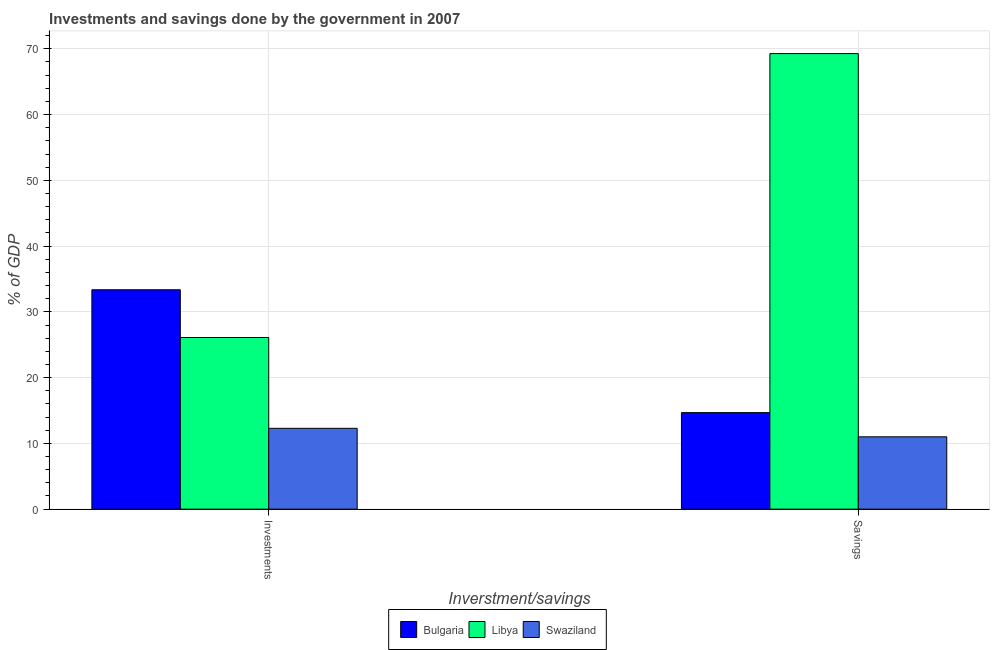How many different coloured bars are there?
Offer a very short reply. 3. Are the number of bars on each tick of the X-axis equal?
Your answer should be very brief. Yes. How many bars are there on the 1st tick from the right?
Make the answer very short. 3. What is the label of the 1st group of bars from the left?
Your answer should be very brief. Investments. What is the investments of government in Swaziland?
Ensure brevity in your answer.  12.29. Across all countries, what is the maximum savings of government?
Offer a terse response. 69.28. Across all countries, what is the minimum savings of government?
Your answer should be very brief. 11. In which country was the savings of government maximum?
Provide a succinct answer. Libya. In which country was the savings of government minimum?
Provide a short and direct response. Swaziland. What is the total investments of government in the graph?
Provide a succinct answer. 71.75. What is the difference between the savings of government in Swaziland and that in Bulgaria?
Keep it short and to the point. -3.68. What is the difference between the savings of government in Swaziland and the investments of government in Bulgaria?
Offer a very short reply. -22.36. What is the average savings of government per country?
Your answer should be compact. 31.65. What is the difference between the savings of government and investments of government in Bulgaria?
Your response must be concise. -18.68. What is the ratio of the investments of government in Bulgaria to that in Libya?
Give a very brief answer. 1.28. Is the investments of government in Bulgaria less than that in Libya?
Your answer should be very brief. No. In how many countries, is the investments of government greater than the average investments of government taken over all countries?
Your response must be concise. 2. What does the 3rd bar from the left in Savings represents?
Provide a short and direct response. Swaziland. What does the 1st bar from the right in Investments represents?
Your answer should be very brief. Swaziland. How many bars are there?
Make the answer very short. 6. Are all the bars in the graph horizontal?
Your answer should be very brief. No. How many countries are there in the graph?
Ensure brevity in your answer.  3. Does the graph contain grids?
Ensure brevity in your answer.  Yes. How many legend labels are there?
Your response must be concise. 3. What is the title of the graph?
Your response must be concise. Investments and savings done by the government in 2007. Does "Canada" appear as one of the legend labels in the graph?
Your answer should be compact. No. What is the label or title of the X-axis?
Your answer should be very brief. Inverstment/savings. What is the label or title of the Y-axis?
Ensure brevity in your answer.  % of GDP. What is the % of GDP in Bulgaria in Investments?
Your answer should be very brief. 33.36. What is the % of GDP of Libya in Investments?
Ensure brevity in your answer.  26.1. What is the % of GDP of Swaziland in Investments?
Ensure brevity in your answer.  12.29. What is the % of GDP in Bulgaria in Savings?
Offer a very short reply. 14.68. What is the % of GDP of Libya in Savings?
Your answer should be compact. 69.28. What is the % of GDP of Swaziland in Savings?
Offer a very short reply. 11. Across all Inverstment/savings, what is the maximum % of GDP in Bulgaria?
Your response must be concise. 33.36. Across all Inverstment/savings, what is the maximum % of GDP in Libya?
Ensure brevity in your answer.  69.28. Across all Inverstment/savings, what is the maximum % of GDP in Swaziland?
Ensure brevity in your answer.  12.29. Across all Inverstment/savings, what is the minimum % of GDP in Bulgaria?
Your response must be concise. 14.68. Across all Inverstment/savings, what is the minimum % of GDP in Libya?
Make the answer very short. 26.1. Across all Inverstment/savings, what is the minimum % of GDP of Swaziland?
Your response must be concise. 11. What is the total % of GDP in Bulgaria in the graph?
Your response must be concise. 48.04. What is the total % of GDP of Libya in the graph?
Keep it short and to the point. 95.38. What is the total % of GDP in Swaziland in the graph?
Give a very brief answer. 23.29. What is the difference between the % of GDP of Bulgaria in Investments and that in Savings?
Keep it short and to the point. 18.68. What is the difference between the % of GDP of Libya in Investments and that in Savings?
Ensure brevity in your answer.  -43.17. What is the difference between the % of GDP in Swaziland in Investments and that in Savings?
Offer a very short reply. 1.29. What is the difference between the % of GDP of Bulgaria in Investments and the % of GDP of Libya in Savings?
Offer a very short reply. -35.91. What is the difference between the % of GDP of Bulgaria in Investments and the % of GDP of Swaziland in Savings?
Make the answer very short. 22.36. What is the difference between the % of GDP of Libya in Investments and the % of GDP of Swaziland in Savings?
Provide a short and direct response. 15.1. What is the average % of GDP of Bulgaria per Inverstment/savings?
Keep it short and to the point. 24.02. What is the average % of GDP in Libya per Inverstment/savings?
Give a very brief answer. 47.69. What is the average % of GDP in Swaziland per Inverstment/savings?
Your answer should be very brief. 11.65. What is the difference between the % of GDP of Bulgaria and % of GDP of Libya in Investments?
Give a very brief answer. 7.26. What is the difference between the % of GDP in Bulgaria and % of GDP in Swaziland in Investments?
Give a very brief answer. 21.07. What is the difference between the % of GDP in Libya and % of GDP in Swaziland in Investments?
Your response must be concise. 13.81. What is the difference between the % of GDP of Bulgaria and % of GDP of Libya in Savings?
Offer a terse response. -54.6. What is the difference between the % of GDP of Bulgaria and % of GDP of Swaziland in Savings?
Offer a very short reply. 3.68. What is the difference between the % of GDP of Libya and % of GDP of Swaziland in Savings?
Your answer should be compact. 58.28. What is the ratio of the % of GDP in Bulgaria in Investments to that in Savings?
Provide a succinct answer. 2.27. What is the ratio of the % of GDP in Libya in Investments to that in Savings?
Offer a terse response. 0.38. What is the ratio of the % of GDP in Swaziland in Investments to that in Savings?
Make the answer very short. 1.12. What is the difference between the highest and the second highest % of GDP of Bulgaria?
Your answer should be compact. 18.68. What is the difference between the highest and the second highest % of GDP of Libya?
Provide a short and direct response. 43.17. What is the difference between the highest and the second highest % of GDP in Swaziland?
Your answer should be very brief. 1.29. What is the difference between the highest and the lowest % of GDP in Bulgaria?
Your answer should be compact. 18.68. What is the difference between the highest and the lowest % of GDP of Libya?
Offer a terse response. 43.17. What is the difference between the highest and the lowest % of GDP in Swaziland?
Make the answer very short. 1.29. 